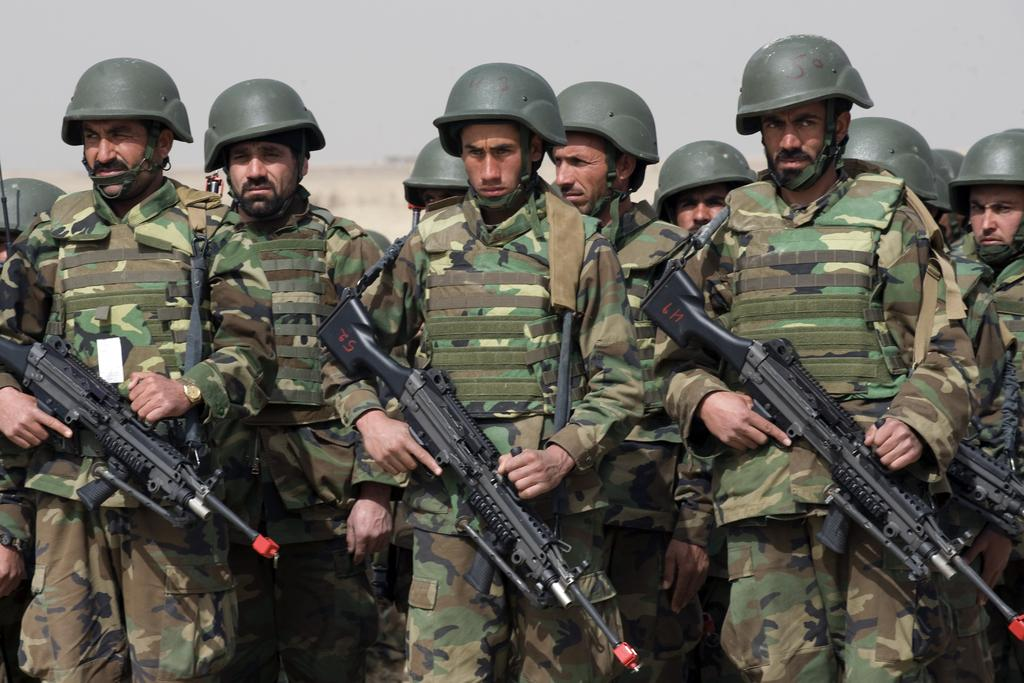What are the people in the foreground of the image holding? The people in the foreground of the image are holding guns. What can be seen in the background of the image? There are buildings in the background of the image. What is visible at the top of the image? The sky is visible at the top of the image. What type of copper material is present in the image? There is no copper material present in the image. How much does the scale weigh in the image? There is no scale present in the image. 